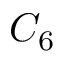<formula> <loc_0><loc_0><loc_500><loc_500>C _ { 6 }</formula> 